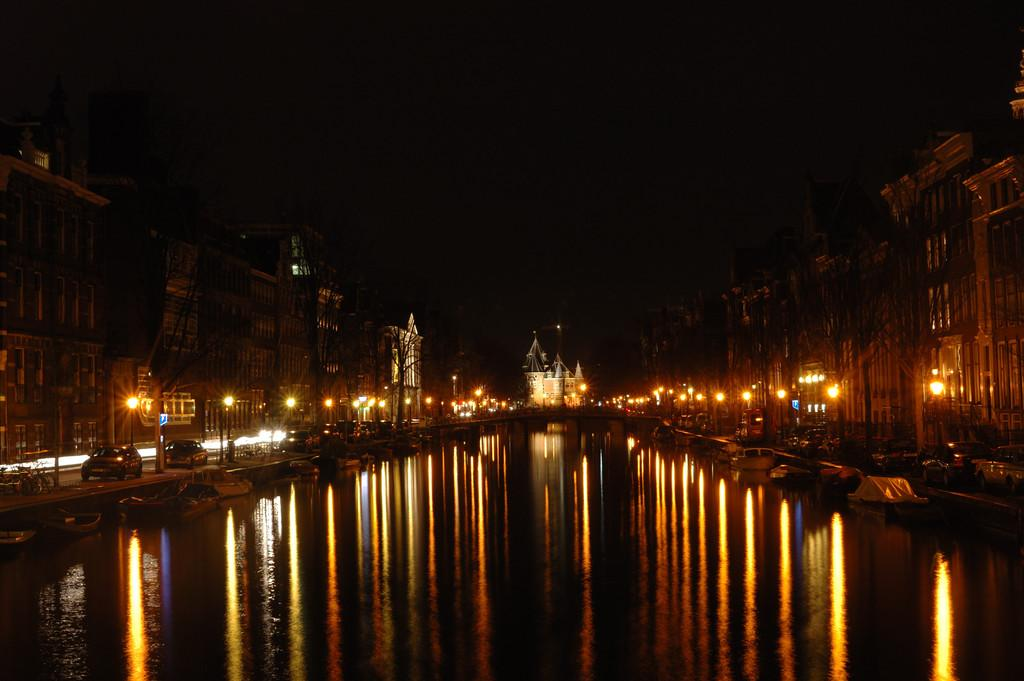What can be seen in the foreground of the image? There is water in the foreground of the image. What is present on either side of the water? There are lights and trees on either side of the water. What else can be seen on either side of the water? There are buildings on either side of the water. What is visible in the background of the image? There is a building in the background of the image, and the sky is dark. What type of vase can be seen in the image? There is no vase present in the image. What recess is visible in the image? There is no recess visible in the image. 